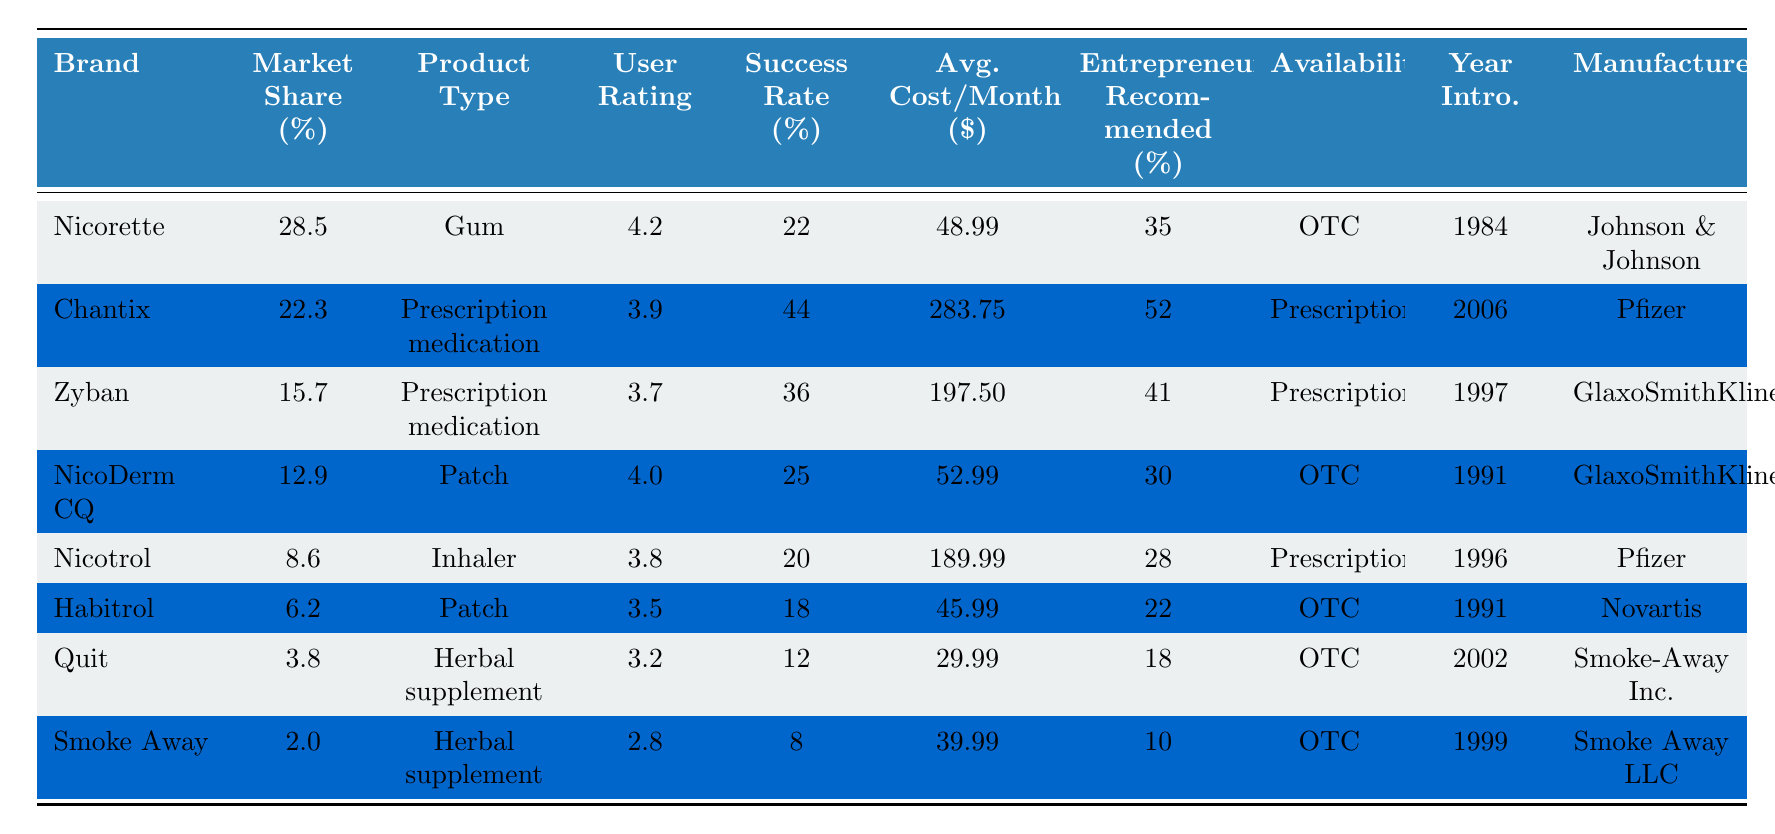What brand has the highest market share? The brand with the highest market share percentage is Nicorette at 28.5%.
Answer: Nicorette What is the success rate of Chantix? The success rate of Chantix is 44%.
Answer: 44% Which product type has the lowest average user rating? The product type with the lowest average user rating is Herbal supplement, with Smoke Away rated at 2.8 and Quit rated at 3.2.
Answer: Herbal supplement What is the average cost of the products recommended by entrepreneurs? The average of the costs is calculated as (48.99 + 283.75 + 197.50 + 52.99 + 189.99 + 45.99 + 29.99 + 39.99) / 8 = 89.61.
Answer: 89.61 Which product, if any, has a higher success rate than its user rating? Chantix has a success rate of 44%, which is higher than its user rating of 3.9.
Answer: Yes What is the total market share of OTC products? The total market share for OTC products is the sum of the market shares of Nicorette, NicoDerm CQ, Habitrol, Quit, and Smoke Away, which is 28.5 + 12.9 + 6.2 + 3.8 + 2.0 = 53.4%.
Answer: 53.4% Which manufacturer produces the most products listed in the table? GlaxoSmithKline produces two products: Zyban and NicoDerm CQ.
Answer: GlaxoSmithKline What is the average user rating of prescription medications? The average user rating for prescription medications is calculated as (3.9 + 3.7 + 3.8) / 3 = 3.8.
Answer: 3.8 Is there any product with a success rate lower than its market share? Yes, Quit has a market share of 3.8% and a success rate of 12%.
Answer: Yes What percentage of products are recommended by entrepreneurs for inhalers? Only Nicotrol is an inhaler that has a recommendation rate of 28%.
Answer: 28% 